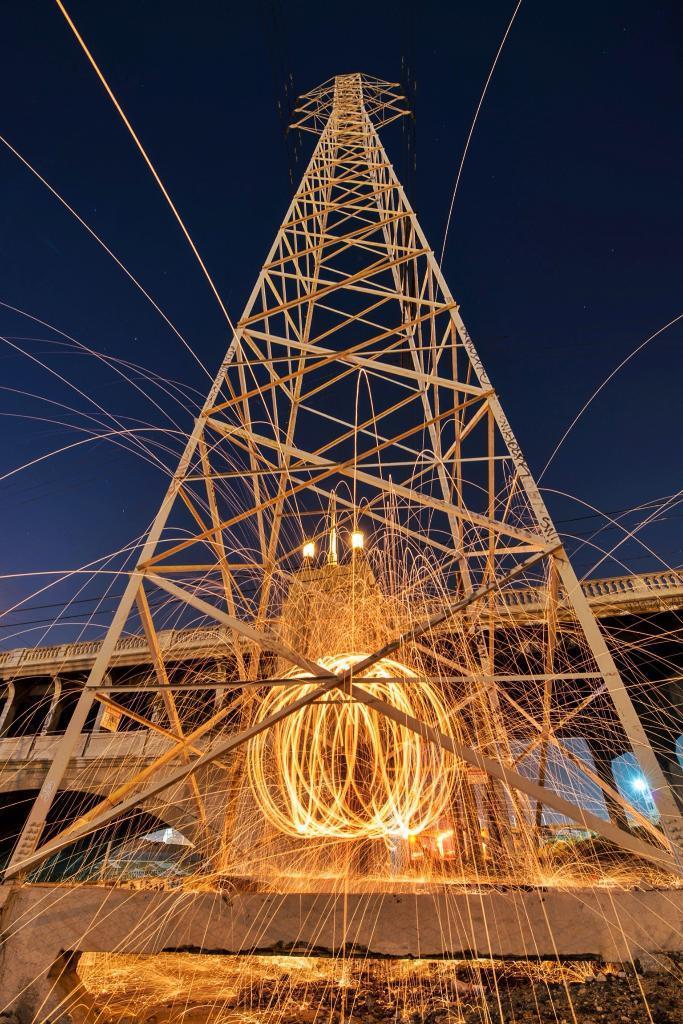In one or two sentences, can you explain what this image depicts? In this image there is a metal rod tower, in the middle of the tower there are fire rings, behind the tower there is a bridge. In the background there is the sky. 